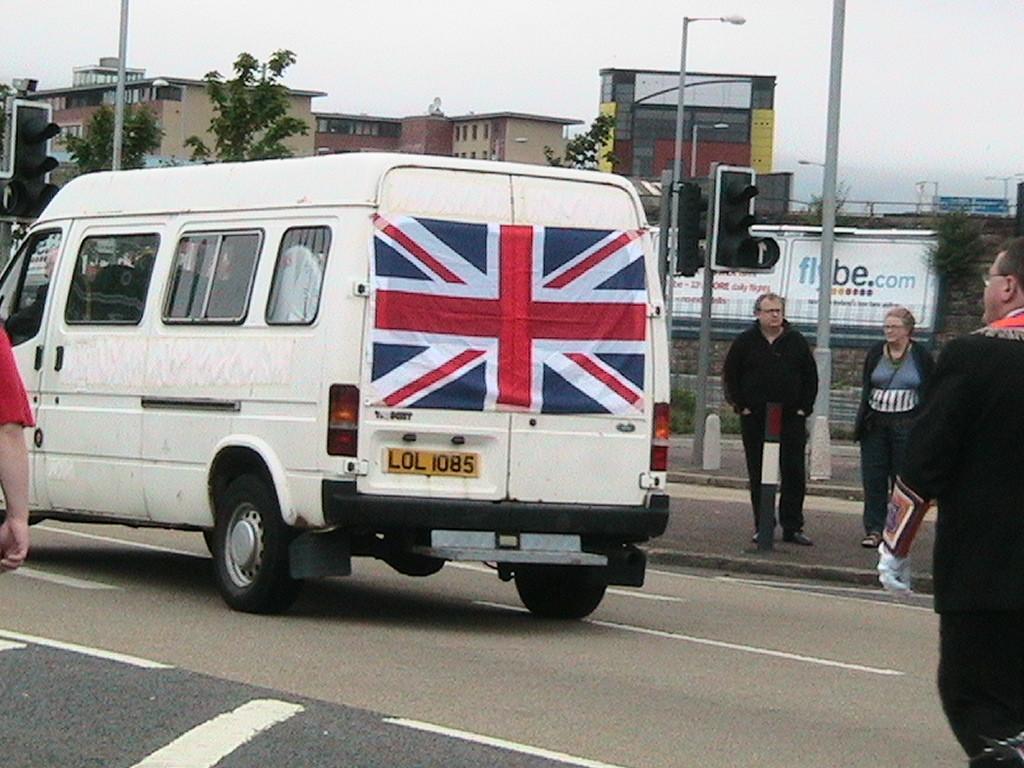How would you summarize this image in a sentence or two? In this image in the center there is a car which is white in colour and on the right side of the car there are persons standing. There are poles, there are boards with some text written on it, and there are buildings. On the left side of the car there is a hand of the person which is visible and in the background there are trees, buildings and the sky is cloudy. 